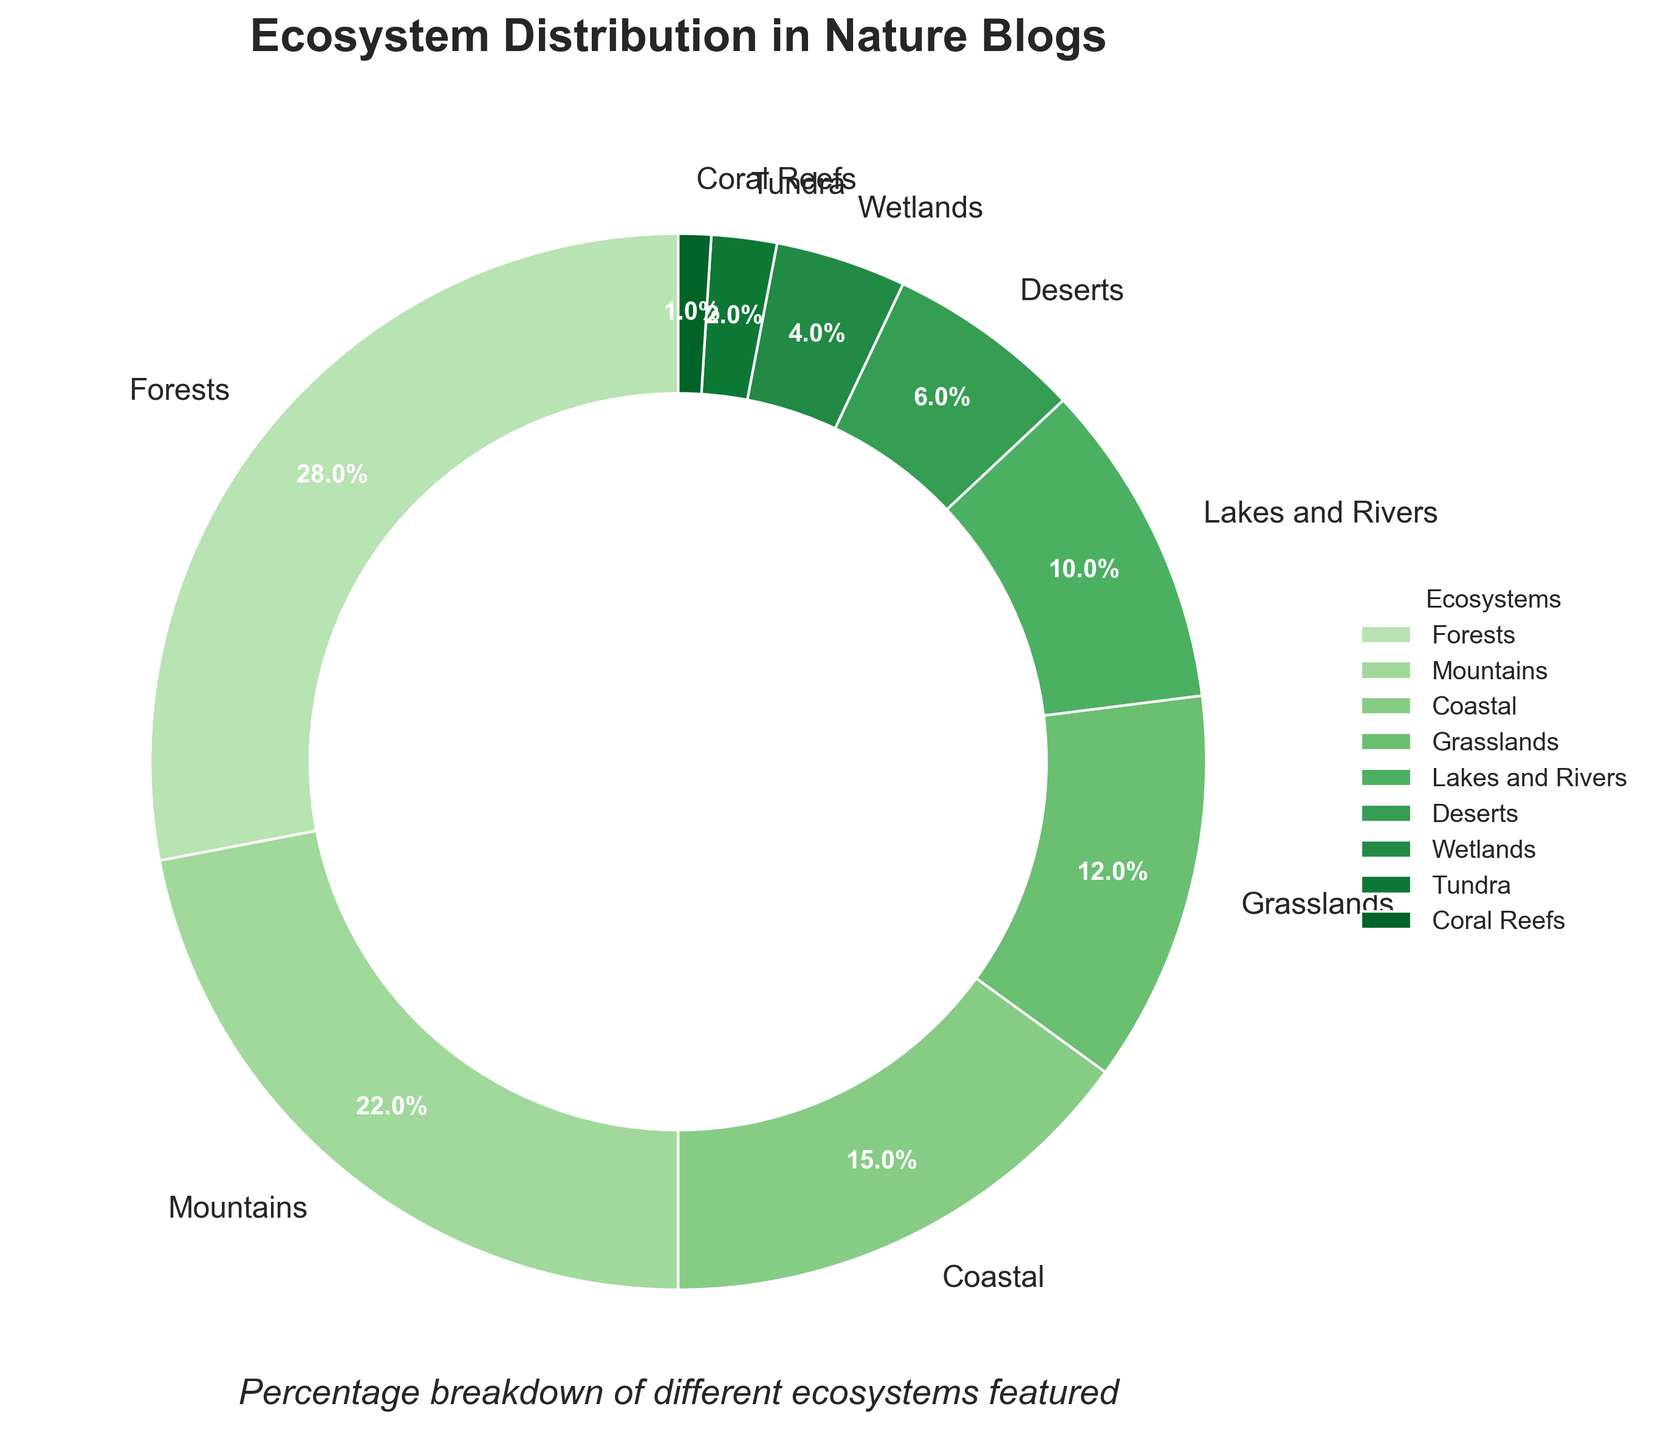What's the combined percentage of terrestrial ecosystems (Forests, Mountains, Grasslands, Deserts, and Tundra)? First, identify the percentages of terrestrial ecosystems: Forests (28%), Mountains (22%), Grasslands (12%), Deserts (6%), and Tundra (2%). Sum these percentages: 28 + 22 + 12 + 6 + 2 = 70%.
Answer: 70% Which ecosystem has a percentage greater than Grasslands but less than Forests? Identify the percentage of Grasslands (12%) and Forests (28%). Then look for the ecosystem within this range. Mountains is at 22%, which fits this condition.
Answer: Mountains What's the percentage difference between Coastal and Wetlands ecosystems? Identify the percentages: Coastal (15%) and Wetlands (4%). Calculate the difference: 15 - 4 = 11%.
Answer: 11% Which ecosystem occupies the smallest percentage in the nature blogs? Look at the ecosystem with the smallest percentage. Coral Reefs occupy 1%.
Answer: Coral Reefs Are there more blogs featuring Lakes and Rivers or Deserts? Compare the percentages of Lakes and Rivers (10%) and Deserts (6%). Lakes and Rivers have a higher percentage.
Answer: Lakes and Rivers What's the total percentage of ecosystems that are below 10% representation? Identify the ecosystems below 10%: Lakes and Rivers (10%), Deserts (6%), Wetlands (4%), Tundra (2%), Coral Reefs (1%). Sum these percentages: 10 + 6 + 4 + 2 + 1 = 23%.
Answer: 23% How does the color vary for the ecosystems with the highest and lowest percentages? Forests, with the highest percentage (28%), has the darkest shade of green, and Coral Reefs, with the lowest percentage (1%), has the lightest shade of green.
Answer: Dark green for Forests, light green for Coral Reefs What percentage of the nature blogs feature water-related ecosystems (Coastal, Lakes and Rivers, Wetlands, Coral Reefs)? Identify the percentages of water-related ecosystems: Coastal (15%), Lakes and Rivers (10%), Wetlands (4%), Coral Reefs (1%). Sum these percentages: 15 + 10 + 4 + 1 = 30%.
Answer: 30% Which ecosystem coverage is equal to half the percentage of Forests? Identify half of Forests' percentage: 28 / 2 = 14%. Check the ecosystems, and Grasslands fall short at 12%, but no ecosystem has exactly 14%. Therefore, none of the ecosystems meet this criterion.
Answer: None How many ecosystems have a representation of 10% or higher? Count the ecosystems with percentages 10% or higher: Forests (28%), Mountains (22%), Coastal (15%), Grasslands (12%), Lakes and Rivers (10%). There are 5 ecosystems.
Answer: 5 